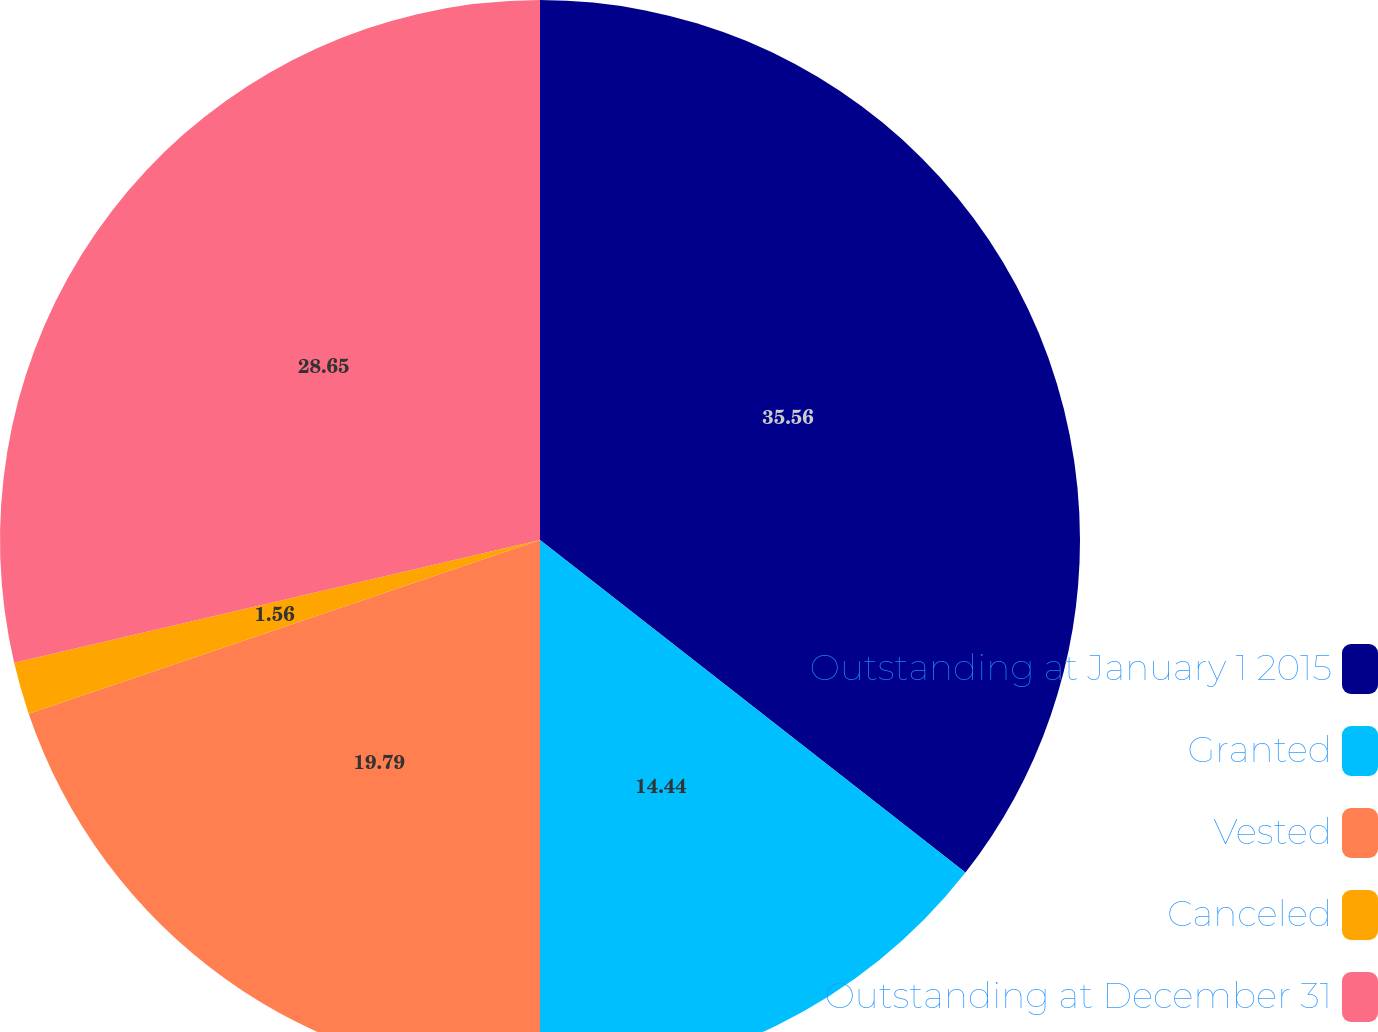Convert chart to OTSL. <chart><loc_0><loc_0><loc_500><loc_500><pie_chart><fcel>Outstanding at January 1 2015<fcel>Granted<fcel>Vested<fcel>Canceled<fcel>Outstanding at December 31<nl><fcel>35.56%<fcel>14.44%<fcel>19.79%<fcel>1.56%<fcel>28.65%<nl></chart> 